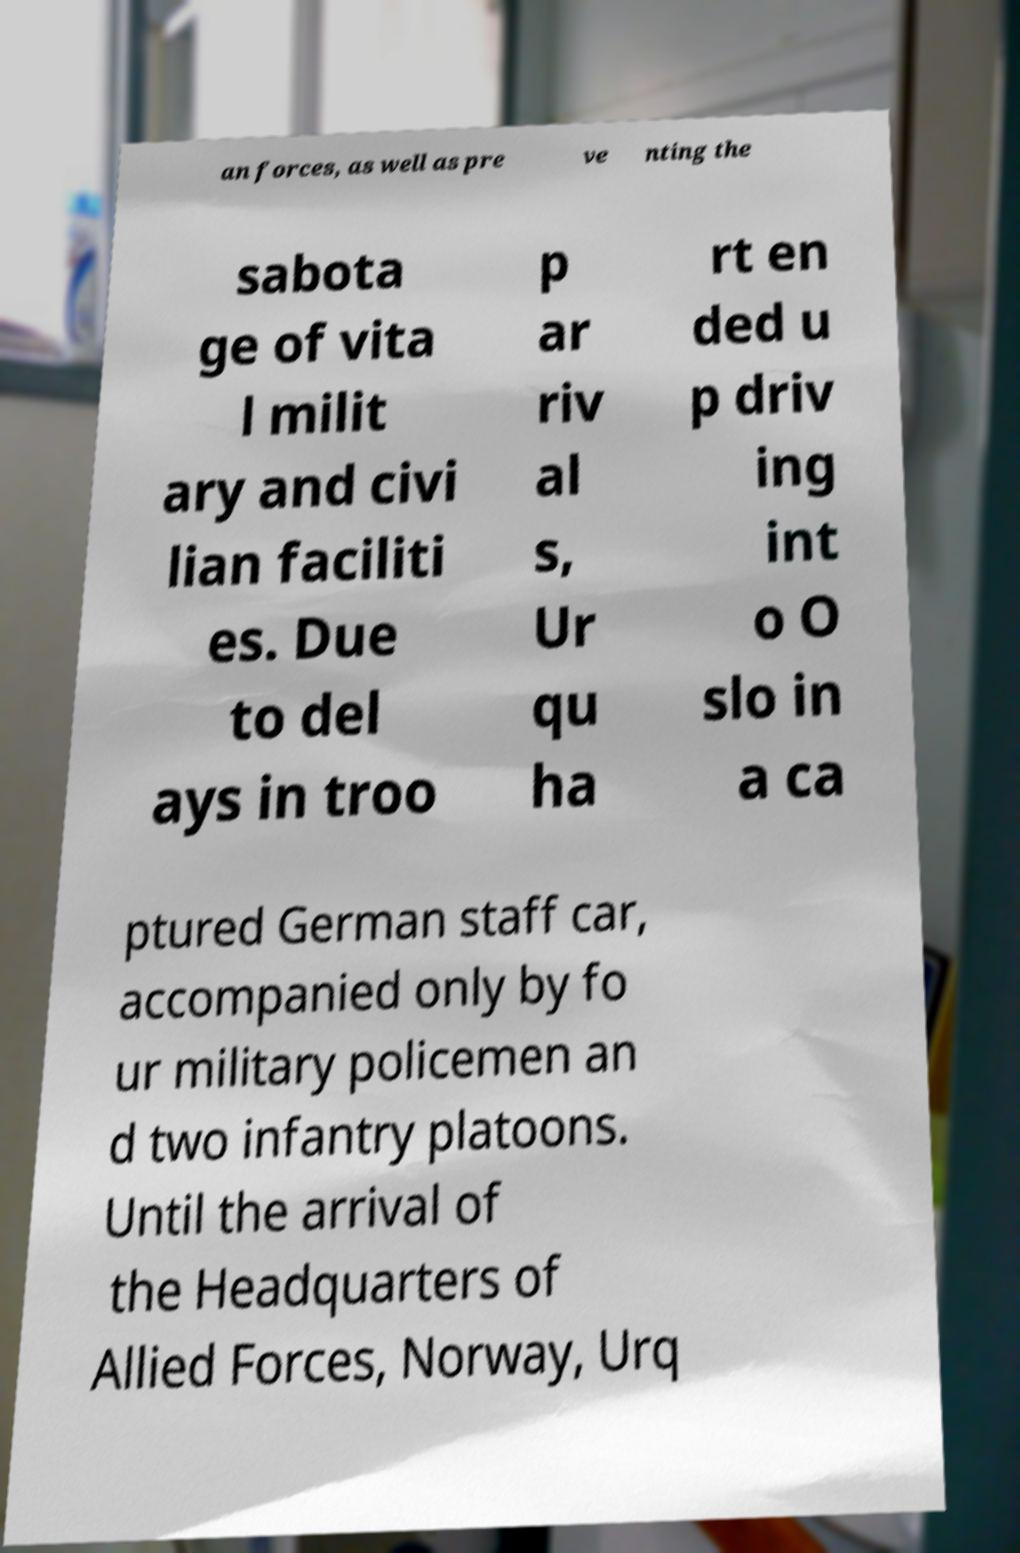Please read and relay the text visible in this image. What does it say? an forces, as well as pre ve nting the sabota ge of vita l milit ary and civi lian faciliti es. Due to del ays in troo p ar riv al s, Ur qu ha rt en ded u p driv ing int o O slo in a ca ptured German staff car, accompanied only by fo ur military policemen an d two infantry platoons. Until the arrival of the Headquarters of Allied Forces, Norway, Urq 